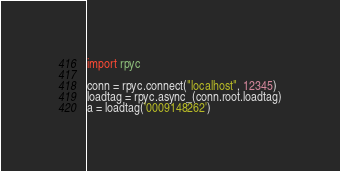Convert code to text. <code><loc_0><loc_0><loc_500><loc_500><_Python_>import rpyc

conn = rpyc.connect("localhost", 12345)
loadtag = rpyc.async_(conn.root.loadtag)
a = loadtag('0009148262')

</code> 